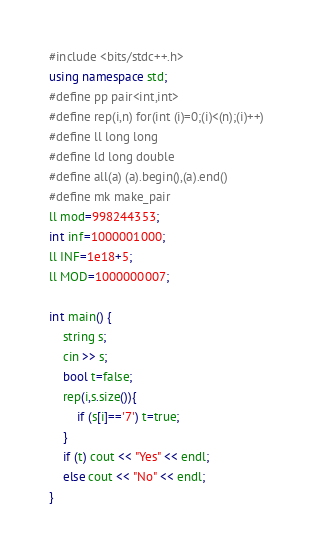Convert code to text. <code><loc_0><loc_0><loc_500><loc_500><_C++_>
#include <bits/stdc++.h>
using namespace std;
#define pp pair<int,int>
#define rep(i,n) for(int (i)=0;(i)<(n);(i)++)
#define ll long long
#define ld long double
#define all(a) (a).begin(),(a).end()
#define mk make_pair
ll mod=998244353;
int inf=1000001000;
ll INF=1e18+5;
ll MOD=1000000007;
 
int main() {
    string s;
    cin >> s;
    bool t=false;
    rep(i,s.size()){
        if (s[i]=='7') t=true;
    }
    if (t) cout << "Yes" << endl;
    else cout << "No" << endl;
}</code> 